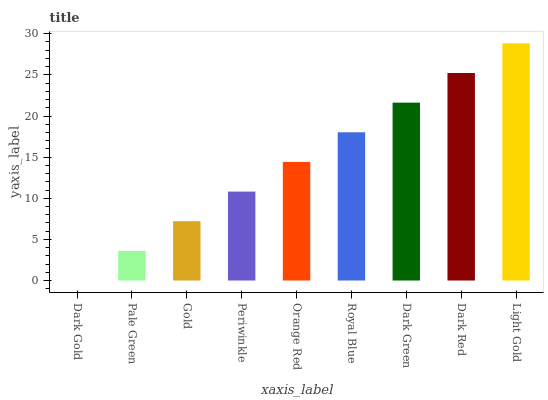Is Dark Gold the minimum?
Answer yes or no. Yes. Is Light Gold the maximum?
Answer yes or no. Yes. Is Pale Green the minimum?
Answer yes or no. No. Is Pale Green the maximum?
Answer yes or no. No. Is Pale Green greater than Dark Gold?
Answer yes or no. Yes. Is Dark Gold less than Pale Green?
Answer yes or no. Yes. Is Dark Gold greater than Pale Green?
Answer yes or no. No. Is Pale Green less than Dark Gold?
Answer yes or no. No. Is Orange Red the high median?
Answer yes or no. Yes. Is Orange Red the low median?
Answer yes or no. Yes. Is Gold the high median?
Answer yes or no. No. Is Dark Red the low median?
Answer yes or no. No. 